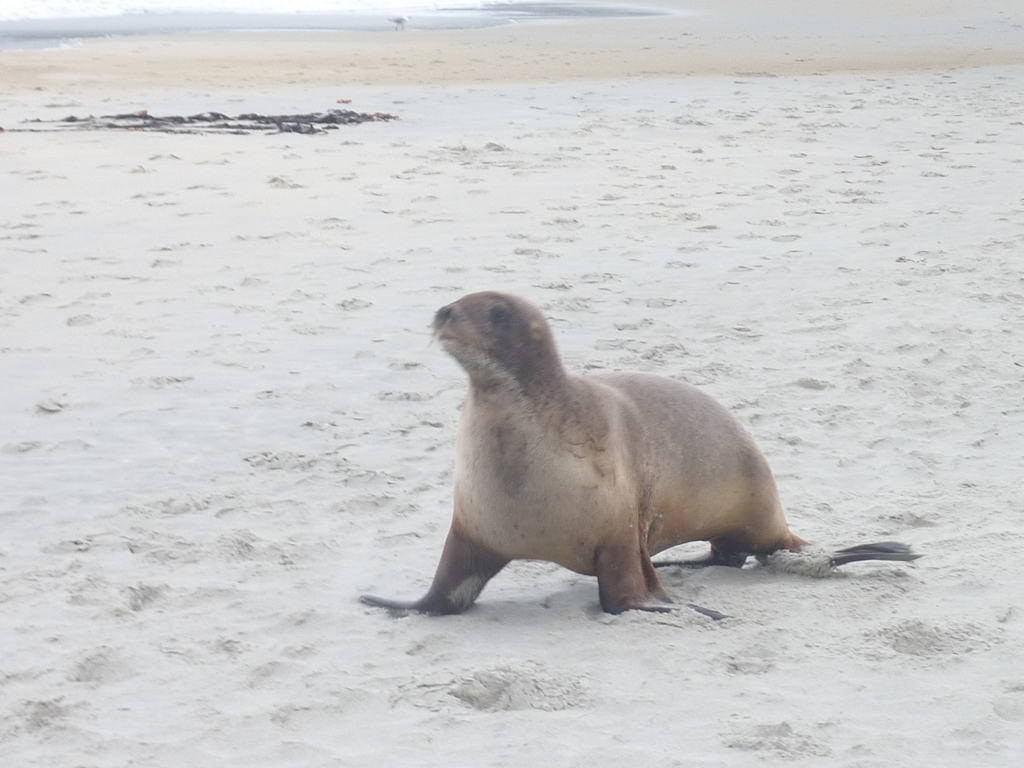Is the image content clear or blurry?
 Blurry. 